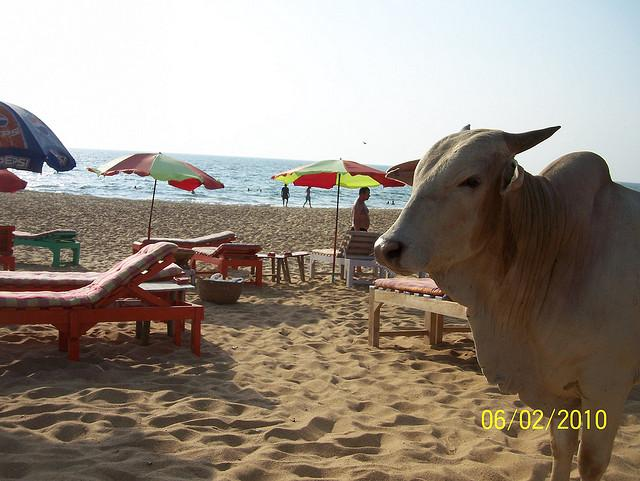Which sentient beings are able to swim? Please explain your reasoning. humans. The humans on the beach are the sentient beings that are able to swim. 